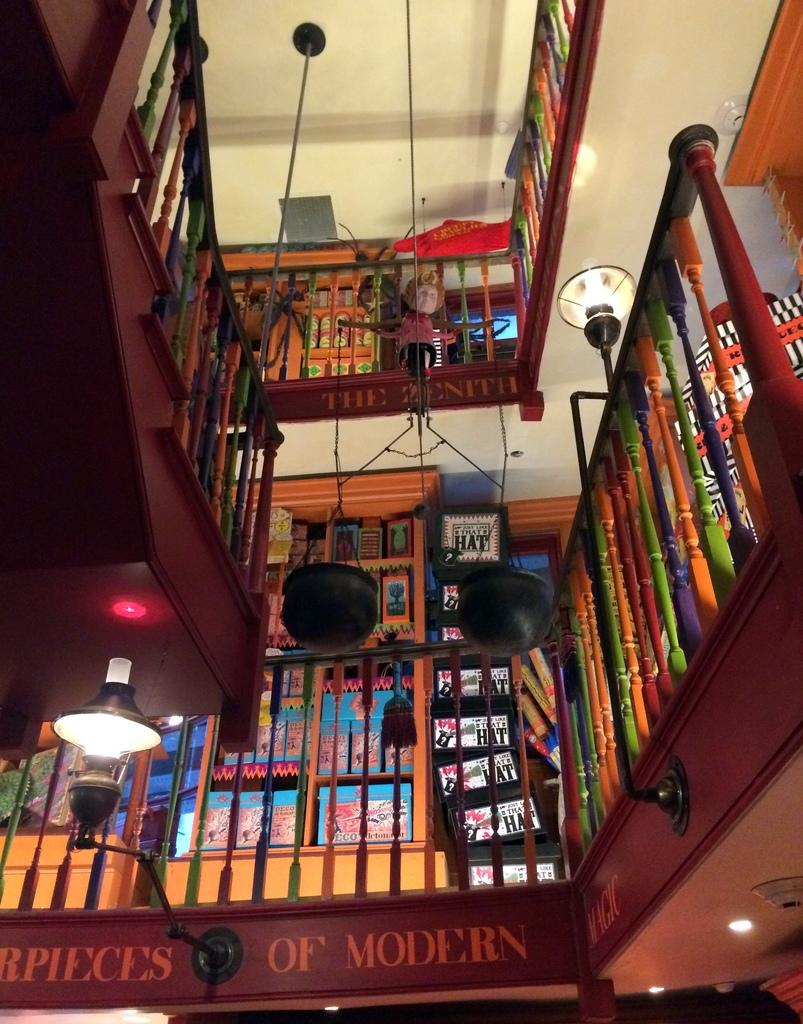What type of structure is visible in the image? There is a building in the image. What feature of the building is mentioned in the facts? The building has stairs. What other objects can be seen in the image? There is a fence, lamps, a doll, and a sign board in the image. What is the building's roof like? The building has a roof. Can you tell me how many clovers are growing near the building in the image? There is no mention of clovers in the image, so it is not possible to determine their presence or quantity. 